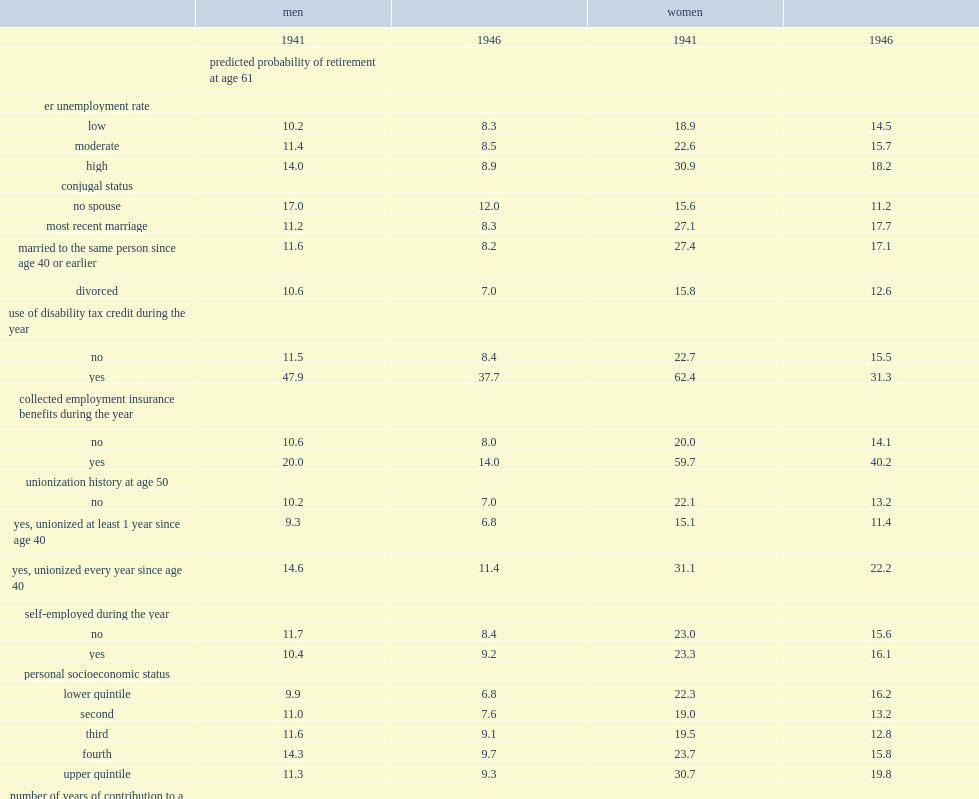For example, how many times did men aged 61 who reported a disability more likely to retire than those who did not in 1941? 4.165217. For example, employed women in the 1941 cohort who had turned 61, and still working, what is the percentage of probability of retiring at that age if they had received employment insurance benefits? 59.7. What is the percentage for women who had not received employment insurance, all other factors remaining constant in 1941? 20.0. 